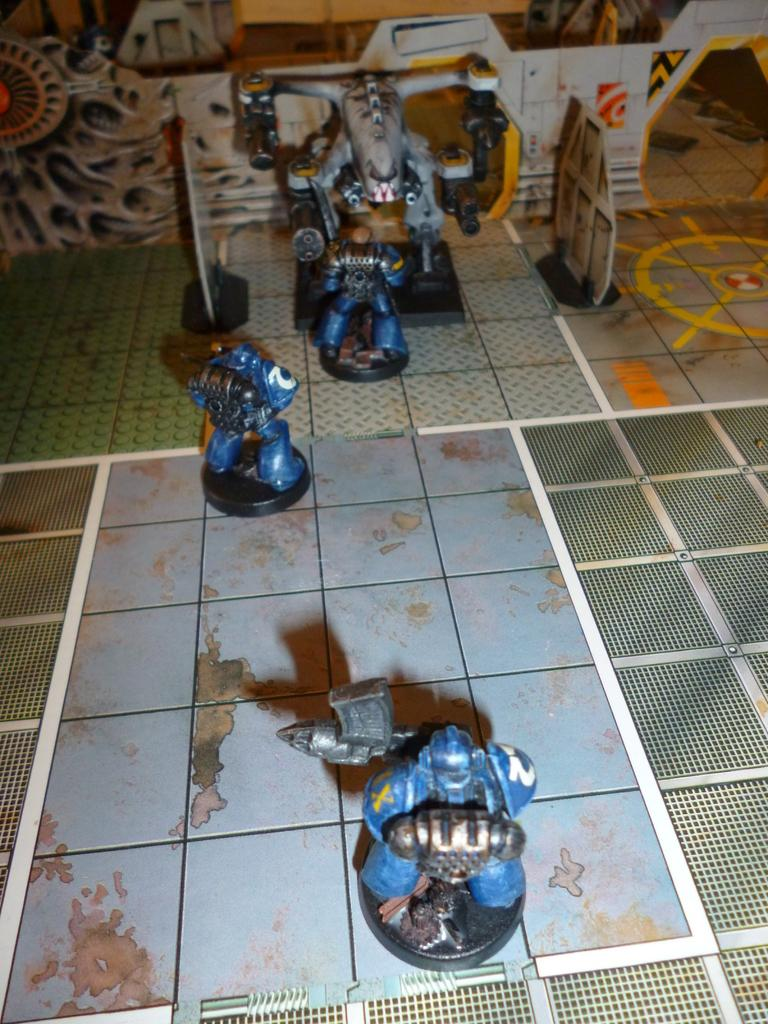What is on the ground in the image? There are toys on the ground. Can you describe any other objects or features in the image? There are other objects in the background. Is there a lake visible in the image? There is no lake present in the image. Can you see any representatives in the image? There is no mention of representatives in the image, as it only features toys on the ground and other objects in the background. 